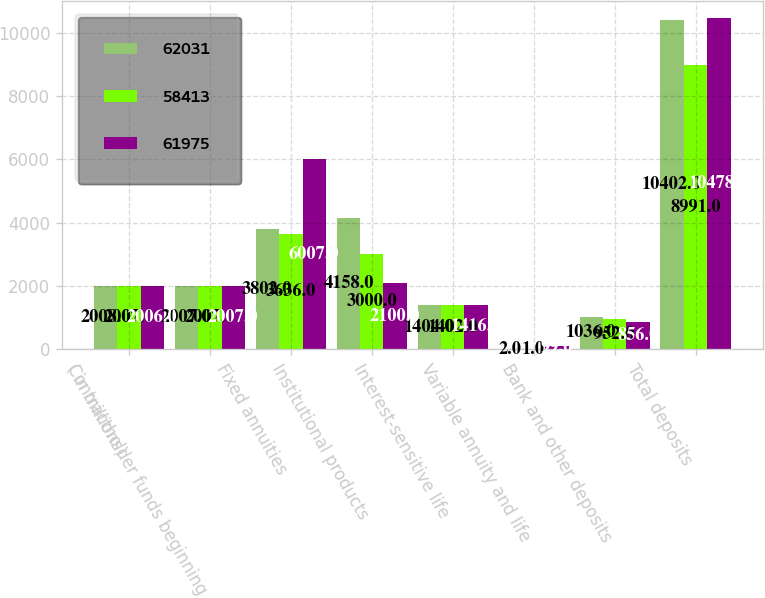Convert chart to OTSL. <chart><loc_0><loc_0><loc_500><loc_500><stacked_bar_chart><ecel><fcel>( in millions)<fcel>Contractholder funds beginning<fcel>Fixed annuities<fcel>Institutional products<fcel>Interest-sensitive life<fcel>Variable annuity and life<fcel>Bank and other deposits<fcel>Total deposits<nl><fcel>62031<fcel>2008<fcel>2007<fcel>3802<fcel>4158<fcel>1404<fcel>2<fcel>1036<fcel>10402<nl><fcel>58413<fcel>2007<fcel>2007<fcel>3636<fcel>3000<fcel>1402<fcel>1<fcel>952<fcel>8991<nl><fcel>61975<fcel>2006<fcel>2007<fcel>6007<fcel>2100<fcel>1416<fcel>99<fcel>856<fcel>10478<nl></chart> 